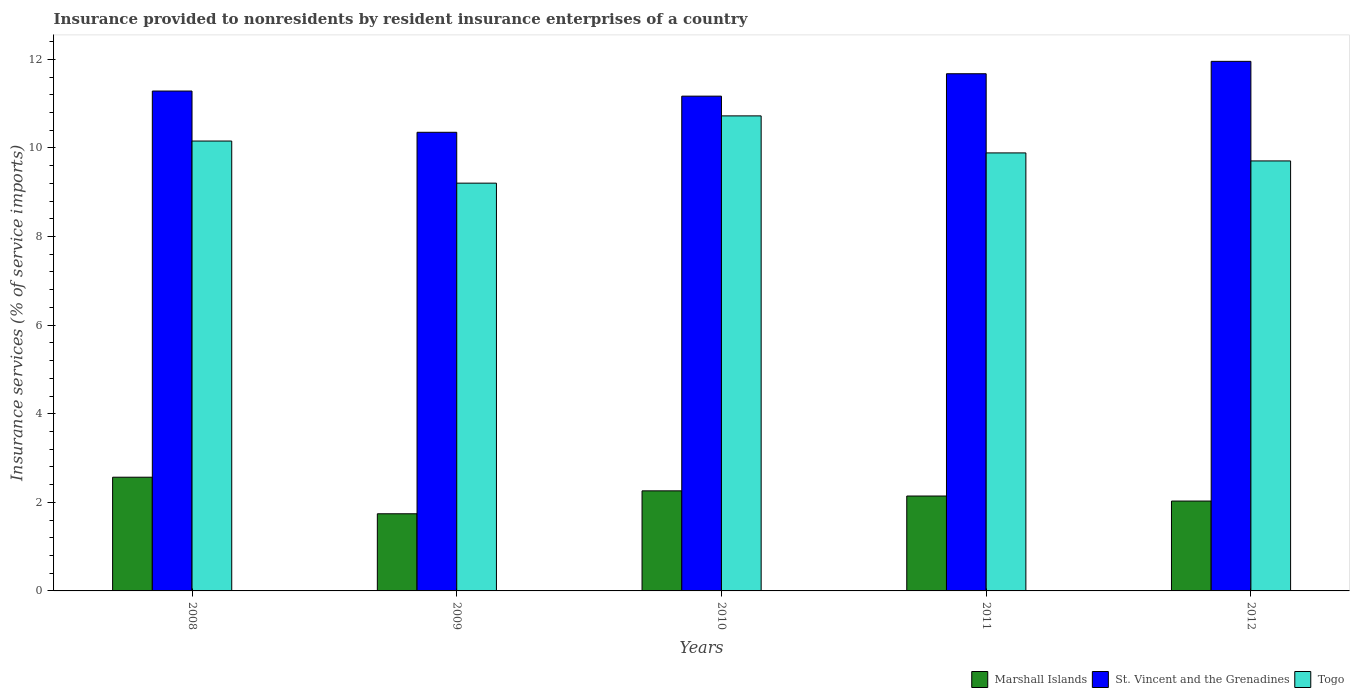How many groups of bars are there?
Provide a short and direct response. 5. Are the number of bars on each tick of the X-axis equal?
Your answer should be compact. Yes. How many bars are there on the 2nd tick from the left?
Offer a terse response. 3. How many bars are there on the 4th tick from the right?
Give a very brief answer. 3. What is the label of the 3rd group of bars from the left?
Provide a succinct answer. 2010. What is the insurance provided to nonresidents in Togo in 2012?
Provide a succinct answer. 9.71. Across all years, what is the maximum insurance provided to nonresidents in Togo?
Offer a very short reply. 10.72. Across all years, what is the minimum insurance provided to nonresidents in St. Vincent and the Grenadines?
Ensure brevity in your answer.  10.35. What is the total insurance provided to nonresidents in Marshall Islands in the graph?
Ensure brevity in your answer.  10.74. What is the difference between the insurance provided to nonresidents in St. Vincent and the Grenadines in 2009 and that in 2012?
Your response must be concise. -1.6. What is the difference between the insurance provided to nonresidents in Marshall Islands in 2010 and the insurance provided to nonresidents in Togo in 2009?
Offer a very short reply. -6.95. What is the average insurance provided to nonresidents in Togo per year?
Your answer should be very brief. 9.94. In the year 2010, what is the difference between the insurance provided to nonresidents in St. Vincent and the Grenadines and insurance provided to nonresidents in Marshall Islands?
Your answer should be very brief. 8.91. What is the ratio of the insurance provided to nonresidents in Marshall Islands in 2008 to that in 2011?
Give a very brief answer. 1.2. Is the insurance provided to nonresidents in Togo in 2008 less than that in 2009?
Give a very brief answer. No. What is the difference between the highest and the second highest insurance provided to nonresidents in Marshall Islands?
Ensure brevity in your answer.  0.31. What is the difference between the highest and the lowest insurance provided to nonresidents in Togo?
Your answer should be compact. 1.52. Is the sum of the insurance provided to nonresidents in St. Vincent and the Grenadines in 2010 and 2012 greater than the maximum insurance provided to nonresidents in Marshall Islands across all years?
Provide a short and direct response. Yes. What does the 2nd bar from the left in 2012 represents?
Your answer should be very brief. St. Vincent and the Grenadines. What does the 1st bar from the right in 2012 represents?
Your response must be concise. Togo. Are all the bars in the graph horizontal?
Offer a terse response. No. Does the graph contain any zero values?
Keep it short and to the point. No. Where does the legend appear in the graph?
Offer a terse response. Bottom right. What is the title of the graph?
Make the answer very short. Insurance provided to nonresidents by resident insurance enterprises of a country. What is the label or title of the Y-axis?
Make the answer very short. Insurance services (% of service imports). What is the Insurance services (% of service imports) in Marshall Islands in 2008?
Offer a terse response. 2.57. What is the Insurance services (% of service imports) of St. Vincent and the Grenadines in 2008?
Give a very brief answer. 11.28. What is the Insurance services (% of service imports) in Togo in 2008?
Give a very brief answer. 10.16. What is the Insurance services (% of service imports) of Marshall Islands in 2009?
Provide a short and direct response. 1.74. What is the Insurance services (% of service imports) in St. Vincent and the Grenadines in 2009?
Your response must be concise. 10.35. What is the Insurance services (% of service imports) of Togo in 2009?
Ensure brevity in your answer.  9.21. What is the Insurance services (% of service imports) in Marshall Islands in 2010?
Your response must be concise. 2.26. What is the Insurance services (% of service imports) in St. Vincent and the Grenadines in 2010?
Provide a short and direct response. 11.17. What is the Insurance services (% of service imports) of Togo in 2010?
Keep it short and to the point. 10.72. What is the Insurance services (% of service imports) in Marshall Islands in 2011?
Your answer should be very brief. 2.14. What is the Insurance services (% of service imports) of St. Vincent and the Grenadines in 2011?
Ensure brevity in your answer.  11.68. What is the Insurance services (% of service imports) of Togo in 2011?
Your answer should be compact. 9.89. What is the Insurance services (% of service imports) in Marshall Islands in 2012?
Ensure brevity in your answer.  2.03. What is the Insurance services (% of service imports) in St. Vincent and the Grenadines in 2012?
Provide a short and direct response. 11.95. What is the Insurance services (% of service imports) in Togo in 2012?
Ensure brevity in your answer.  9.71. Across all years, what is the maximum Insurance services (% of service imports) of Marshall Islands?
Your answer should be very brief. 2.57. Across all years, what is the maximum Insurance services (% of service imports) of St. Vincent and the Grenadines?
Your answer should be compact. 11.95. Across all years, what is the maximum Insurance services (% of service imports) of Togo?
Ensure brevity in your answer.  10.72. Across all years, what is the minimum Insurance services (% of service imports) of Marshall Islands?
Your answer should be very brief. 1.74. Across all years, what is the minimum Insurance services (% of service imports) of St. Vincent and the Grenadines?
Ensure brevity in your answer.  10.35. Across all years, what is the minimum Insurance services (% of service imports) of Togo?
Provide a succinct answer. 9.21. What is the total Insurance services (% of service imports) in Marshall Islands in the graph?
Keep it short and to the point. 10.74. What is the total Insurance services (% of service imports) in St. Vincent and the Grenadines in the graph?
Make the answer very short. 56.44. What is the total Insurance services (% of service imports) of Togo in the graph?
Give a very brief answer. 49.68. What is the difference between the Insurance services (% of service imports) in Marshall Islands in 2008 and that in 2009?
Your response must be concise. 0.83. What is the difference between the Insurance services (% of service imports) in St. Vincent and the Grenadines in 2008 and that in 2009?
Offer a terse response. 0.93. What is the difference between the Insurance services (% of service imports) in Togo in 2008 and that in 2009?
Provide a short and direct response. 0.95. What is the difference between the Insurance services (% of service imports) of Marshall Islands in 2008 and that in 2010?
Your response must be concise. 0.31. What is the difference between the Insurance services (% of service imports) in St. Vincent and the Grenadines in 2008 and that in 2010?
Make the answer very short. 0.12. What is the difference between the Insurance services (% of service imports) of Togo in 2008 and that in 2010?
Offer a terse response. -0.57. What is the difference between the Insurance services (% of service imports) in Marshall Islands in 2008 and that in 2011?
Provide a short and direct response. 0.42. What is the difference between the Insurance services (% of service imports) in St. Vincent and the Grenadines in 2008 and that in 2011?
Your response must be concise. -0.39. What is the difference between the Insurance services (% of service imports) in Togo in 2008 and that in 2011?
Keep it short and to the point. 0.27. What is the difference between the Insurance services (% of service imports) in Marshall Islands in 2008 and that in 2012?
Make the answer very short. 0.54. What is the difference between the Insurance services (% of service imports) in St. Vincent and the Grenadines in 2008 and that in 2012?
Your response must be concise. -0.67. What is the difference between the Insurance services (% of service imports) of Togo in 2008 and that in 2012?
Give a very brief answer. 0.45. What is the difference between the Insurance services (% of service imports) of Marshall Islands in 2009 and that in 2010?
Give a very brief answer. -0.52. What is the difference between the Insurance services (% of service imports) in St. Vincent and the Grenadines in 2009 and that in 2010?
Offer a terse response. -0.82. What is the difference between the Insurance services (% of service imports) of Togo in 2009 and that in 2010?
Your answer should be compact. -1.52. What is the difference between the Insurance services (% of service imports) in Marshall Islands in 2009 and that in 2011?
Make the answer very short. -0.4. What is the difference between the Insurance services (% of service imports) in St. Vincent and the Grenadines in 2009 and that in 2011?
Ensure brevity in your answer.  -1.32. What is the difference between the Insurance services (% of service imports) of Togo in 2009 and that in 2011?
Offer a very short reply. -0.68. What is the difference between the Insurance services (% of service imports) in Marshall Islands in 2009 and that in 2012?
Give a very brief answer. -0.29. What is the difference between the Insurance services (% of service imports) in St. Vincent and the Grenadines in 2009 and that in 2012?
Your answer should be compact. -1.6. What is the difference between the Insurance services (% of service imports) in Togo in 2009 and that in 2012?
Ensure brevity in your answer.  -0.5. What is the difference between the Insurance services (% of service imports) in Marshall Islands in 2010 and that in 2011?
Make the answer very short. 0.12. What is the difference between the Insurance services (% of service imports) of St. Vincent and the Grenadines in 2010 and that in 2011?
Make the answer very short. -0.51. What is the difference between the Insurance services (% of service imports) of Togo in 2010 and that in 2011?
Offer a terse response. 0.84. What is the difference between the Insurance services (% of service imports) in Marshall Islands in 2010 and that in 2012?
Give a very brief answer. 0.23. What is the difference between the Insurance services (% of service imports) of St. Vincent and the Grenadines in 2010 and that in 2012?
Keep it short and to the point. -0.79. What is the difference between the Insurance services (% of service imports) of Togo in 2010 and that in 2012?
Offer a terse response. 1.02. What is the difference between the Insurance services (% of service imports) of Marshall Islands in 2011 and that in 2012?
Provide a succinct answer. 0.11. What is the difference between the Insurance services (% of service imports) in St. Vincent and the Grenadines in 2011 and that in 2012?
Keep it short and to the point. -0.28. What is the difference between the Insurance services (% of service imports) in Togo in 2011 and that in 2012?
Offer a very short reply. 0.18. What is the difference between the Insurance services (% of service imports) in Marshall Islands in 2008 and the Insurance services (% of service imports) in St. Vincent and the Grenadines in 2009?
Ensure brevity in your answer.  -7.79. What is the difference between the Insurance services (% of service imports) in Marshall Islands in 2008 and the Insurance services (% of service imports) in Togo in 2009?
Your response must be concise. -6.64. What is the difference between the Insurance services (% of service imports) of St. Vincent and the Grenadines in 2008 and the Insurance services (% of service imports) of Togo in 2009?
Provide a succinct answer. 2.08. What is the difference between the Insurance services (% of service imports) in Marshall Islands in 2008 and the Insurance services (% of service imports) in St. Vincent and the Grenadines in 2010?
Offer a very short reply. -8.6. What is the difference between the Insurance services (% of service imports) of Marshall Islands in 2008 and the Insurance services (% of service imports) of Togo in 2010?
Your answer should be very brief. -8.16. What is the difference between the Insurance services (% of service imports) of St. Vincent and the Grenadines in 2008 and the Insurance services (% of service imports) of Togo in 2010?
Ensure brevity in your answer.  0.56. What is the difference between the Insurance services (% of service imports) of Marshall Islands in 2008 and the Insurance services (% of service imports) of St. Vincent and the Grenadines in 2011?
Ensure brevity in your answer.  -9.11. What is the difference between the Insurance services (% of service imports) in Marshall Islands in 2008 and the Insurance services (% of service imports) in Togo in 2011?
Your answer should be very brief. -7.32. What is the difference between the Insurance services (% of service imports) in St. Vincent and the Grenadines in 2008 and the Insurance services (% of service imports) in Togo in 2011?
Keep it short and to the point. 1.4. What is the difference between the Insurance services (% of service imports) in Marshall Islands in 2008 and the Insurance services (% of service imports) in St. Vincent and the Grenadines in 2012?
Your answer should be compact. -9.39. What is the difference between the Insurance services (% of service imports) in Marshall Islands in 2008 and the Insurance services (% of service imports) in Togo in 2012?
Ensure brevity in your answer.  -7.14. What is the difference between the Insurance services (% of service imports) in St. Vincent and the Grenadines in 2008 and the Insurance services (% of service imports) in Togo in 2012?
Your answer should be compact. 1.58. What is the difference between the Insurance services (% of service imports) in Marshall Islands in 2009 and the Insurance services (% of service imports) in St. Vincent and the Grenadines in 2010?
Provide a short and direct response. -9.43. What is the difference between the Insurance services (% of service imports) in Marshall Islands in 2009 and the Insurance services (% of service imports) in Togo in 2010?
Ensure brevity in your answer.  -8.98. What is the difference between the Insurance services (% of service imports) of St. Vincent and the Grenadines in 2009 and the Insurance services (% of service imports) of Togo in 2010?
Ensure brevity in your answer.  -0.37. What is the difference between the Insurance services (% of service imports) of Marshall Islands in 2009 and the Insurance services (% of service imports) of St. Vincent and the Grenadines in 2011?
Your response must be concise. -9.93. What is the difference between the Insurance services (% of service imports) of Marshall Islands in 2009 and the Insurance services (% of service imports) of Togo in 2011?
Your answer should be compact. -8.15. What is the difference between the Insurance services (% of service imports) of St. Vincent and the Grenadines in 2009 and the Insurance services (% of service imports) of Togo in 2011?
Keep it short and to the point. 0.47. What is the difference between the Insurance services (% of service imports) of Marshall Islands in 2009 and the Insurance services (% of service imports) of St. Vincent and the Grenadines in 2012?
Keep it short and to the point. -10.21. What is the difference between the Insurance services (% of service imports) of Marshall Islands in 2009 and the Insurance services (% of service imports) of Togo in 2012?
Ensure brevity in your answer.  -7.97. What is the difference between the Insurance services (% of service imports) of St. Vincent and the Grenadines in 2009 and the Insurance services (% of service imports) of Togo in 2012?
Provide a succinct answer. 0.65. What is the difference between the Insurance services (% of service imports) in Marshall Islands in 2010 and the Insurance services (% of service imports) in St. Vincent and the Grenadines in 2011?
Offer a terse response. -9.42. What is the difference between the Insurance services (% of service imports) of Marshall Islands in 2010 and the Insurance services (% of service imports) of Togo in 2011?
Ensure brevity in your answer.  -7.63. What is the difference between the Insurance services (% of service imports) in St. Vincent and the Grenadines in 2010 and the Insurance services (% of service imports) in Togo in 2011?
Offer a very short reply. 1.28. What is the difference between the Insurance services (% of service imports) in Marshall Islands in 2010 and the Insurance services (% of service imports) in St. Vincent and the Grenadines in 2012?
Make the answer very short. -9.7. What is the difference between the Insurance services (% of service imports) of Marshall Islands in 2010 and the Insurance services (% of service imports) of Togo in 2012?
Give a very brief answer. -7.45. What is the difference between the Insurance services (% of service imports) of St. Vincent and the Grenadines in 2010 and the Insurance services (% of service imports) of Togo in 2012?
Your answer should be compact. 1.46. What is the difference between the Insurance services (% of service imports) of Marshall Islands in 2011 and the Insurance services (% of service imports) of St. Vincent and the Grenadines in 2012?
Offer a very short reply. -9.81. What is the difference between the Insurance services (% of service imports) in Marshall Islands in 2011 and the Insurance services (% of service imports) in Togo in 2012?
Ensure brevity in your answer.  -7.56. What is the difference between the Insurance services (% of service imports) in St. Vincent and the Grenadines in 2011 and the Insurance services (% of service imports) in Togo in 2012?
Your answer should be very brief. 1.97. What is the average Insurance services (% of service imports) in Marshall Islands per year?
Offer a terse response. 2.15. What is the average Insurance services (% of service imports) in St. Vincent and the Grenadines per year?
Your response must be concise. 11.29. What is the average Insurance services (% of service imports) of Togo per year?
Your response must be concise. 9.94. In the year 2008, what is the difference between the Insurance services (% of service imports) in Marshall Islands and Insurance services (% of service imports) in St. Vincent and the Grenadines?
Provide a succinct answer. -8.72. In the year 2008, what is the difference between the Insurance services (% of service imports) in Marshall Islands and Insurance services (% of service imports) in Togo?
Your response must be concise. -7.59. In the year 2008, what is the difference between the Insurance services (% of service imports) in St. Vincent and the Grenadines and Insurance services (% of service imports) in Togo?
Provide a short and direct response. 1.13. In the year 2009, what is the difference between the Insurance services (% of service imports) of Marshall Islands and Insurance services (% of service imports) of St. Vincent and the Grenadines?
Give a very brief answer. -8.61. In the year 2009, what is the difference between the Insurance services (% of service imports) of Marshall Islands and Insurance services (% of service imports) of Togo?
Provide a short and direct response. -7.46. In the year 2009, what is the difference between the Insurance services (% of service imports) of St. Vincent and the Grenadines and Insurance services (% of service imports) of Togo?
Ensure brevity in your answer.  1.15. In the year 2010, what is the difference between the Insurance services (% of service imports) in Marshall Islands and Insurance services (% of service imports) in St. Vincent and the Grenadines?
Offer a terse response. -8.91. In the year 2010, what is the difference between the Insurance services (% of service imports) of Marshall Islands and Insurance services (% of service imports) of Togo?
Provide a succinct answer. -8.46. In the year 2010, what is the difference between the Insurance services (% of service imports) of St. Vincent and the Grenadines and Insurance services (% of service imports) of Togo?
Provide a short and direct response. 0.45. In the year 2011, what is the difference between the Insurance services (% of service imports) of Marshall Islands and Insurance services (% of service imports) of St. Vincent and the Grenadines?
Your response must be concise. -9.53. In the year 2011, what is the difference between the Insurance services (% of service imports) of Marshall Islands and Insurance services (% of service imports) of Togo?
Give a very brief answer. -7.75. In the year 2011, what is the difference between the Insurance services (% of service imports) of St. Vincent and the Grenadines and Insurance services (% of service imports) of Togo?
Your answer should be very brief. 1.79. In the year 2012, what is the difference between the Insurance services (% of service imports) of Marshall Islands and Insurance services (% of service imports) of St. Vincent and the Grenadines?
Your answer should be very brief. -9.93. In the year 2012, what is the difference between the Insurance services (% of service imports) in Marshall Islands and Insurance services (% of service imports) in Togo?
Ensure brevity in your answer.  -7.68. In the year 2012, what is the difference between the Insurance services (% of service imports) of St. Vincent and the Grenadines and Insurance services (% of service imports) of Togo?
Give a very brief answer. 2.25. What is the ratio of the Insurance services (% of service imports) in Marshall Islands in 2008 to that in 2009?
Your answer should be compact. 1.47. What is the ratio of the Insurance services (% of service imports) of St. Vincent and the Grenadines in 2008 to that in 2009?
Offer a very short reply. 1.09. What is the ratio of the Insurance services (% of service imports) in Togo in 2008 to that in 2009?
Make the answer very short. 1.1. What is the ratio of the Insurance services (% of service imports) in Marshall Islands in 2008 to that in 2010?
Your answer should be compact. 1.14. What is the ratio of the Insurance services (% of service imports) in St. Vincent and the Grenadines in 2008 to that in 2010?
Your answer should be compact. 1.01. What is the ratio of the Insurance services (% of service imports) of Togo in 2008 to that in 2010?
Ensure brevity in your answer.  0.95. What is the ratio of the Insurance services (% of service imports) in Marshall Islands in 2008 to that in 2011?
Give a very brief answer. 1.2. What is the ratio of the Insurance services (% of service imports) of St. Vincent and the Grenadines in 2008 to that in 2011?
Give a very brief answer. 0.97. What is the ratio of the Insurance services (% of service imports) in Togo in 2008 to that in 2011?
Your answer should be compact. 1.03. What is the ratio of the Insurance services (% of service imports) of Marshall Islands in 2008 to that in 2012?
Your answer should be compact. 1.27. What is the ratio of the Insurance services (% of service imports) in St. Vincent and the Grenadines in 2008 to that in 2012?
Offer a very short reply. 0.94. What is the ratio of the Insurance services (% of service imports) of Togo in 2008 to that in 2012?
Provide a succinct answer. 1.05. What is the ratio of the Insurance services (% of service imports) in Marshall Islands in 2009 to that in 2010?
Your answer should be very brief. 0.77. What is the ratio of the Insurance services (% of service imports) of St. Vincent and the Grenadines in 2009 to that in 2010?
Your response must be concise. 0.93. What is the ratio of the Insurance services (% of service imports) in Togo in 2009 to that in 2010?
Your answer should be very brief. 0.86. What is the ratio of the Insurance services (% of service imports) in Marshall Islands in 2009 to that in 2011?
Your answer should be very brief. 0.81. What is the ratio of the Insurance services (% of service imports) of St. Vincent and the Grenadines in 2009 to that in 2011?
Offer a terse response. 0.89. What is the ratio of the Insurance services (% of service imports) in Togo in 2009 to that in 2011?
Provide a short and direct response. 0.93. What is the ratio of the Insurance services (% of service imports) in Marshall Islands in 2009 to that in 2012?
Provide a succinct answer. 0.86. What is the ratio of the Insurance services (% of service imports) in St. Vincent and the Grenadines in 2009 to that in 2012?
Ensure brevity in your answer.  0.87. What is the ratio of the Insurance services (% of service imports) of Togo in 2009 to that in 2012?
Keep it short and to the point. 0.95. What is the ratio of the Insurance services (% of service imports) of Marshall Islands in 2010 to that in 2011?
Your response must be concise. 1.05. What is the ratio of the Insurance services (% of service imports) in St. Vincent and the Grenadines in 2010 to that in 2011?
Ensure brevity in your answer.  0.96. What is the ratio of the Insurance services (% of service imports) in Togo in 2010 to that in 2011?
Ensure brevity in your answer.  1.08. What is the ratio of the Insurance services (% of service imports) of Marshall Islands in 2010 to that in 2012?
Give a very brief answer. 1.11. What is the ratio of the Insurance services (% of service imports) of St. Vincent and the Grenadines in 2010 to that in 2012?
Provide a succinct answer. 0.93. What is the ratio of the Insurance services (% of service imports) of Togo in 2010 to that in 2012?
Offer a very short reply. 1.1. What is the ratio of the Insurance services (% of service imports) of Marshall Islands in 2011 to that in 2012?
Ensure brevity in your answer.  1.06. What is the ratio of the Insurance services (% of service imports) of St. Vincent and the Grenadines in 2011 to that in 2012?
Offer a terse response. 0.98. What is the ratio of the Insurance services (% of service imports) of Togo in 2011 to that in 2012?
Ensure brevity in your answer.  1.02. What is the difference between the highest and the second highest Insurance services (% of service imports) of Marshall Islands?
Keep it short and to the point. 0.31. What is the difference between the highest and the second highest Insurance services (% of service imports) in St. Vincent and the Grenadines?
Your response must be concise. 0.28. What is the difference between the highest and the second highest Insurance services (% of service imports) in Togo?
Offer a terse response. 0.57. What is the difference between the highest and the lowest Insurance services (% of service imports) in Marshall Islands?
Make the answer very short. 0.83. What is the difference between the highest and the lowest Insurance services (% of service imports) of St. Vincent and the Grenadines?
Keep it short and to the point. 1.6. What is the difference between the highest and the lowest Insurance services (% of service imports) in Togo?
Offer a terse response. 1.52. 